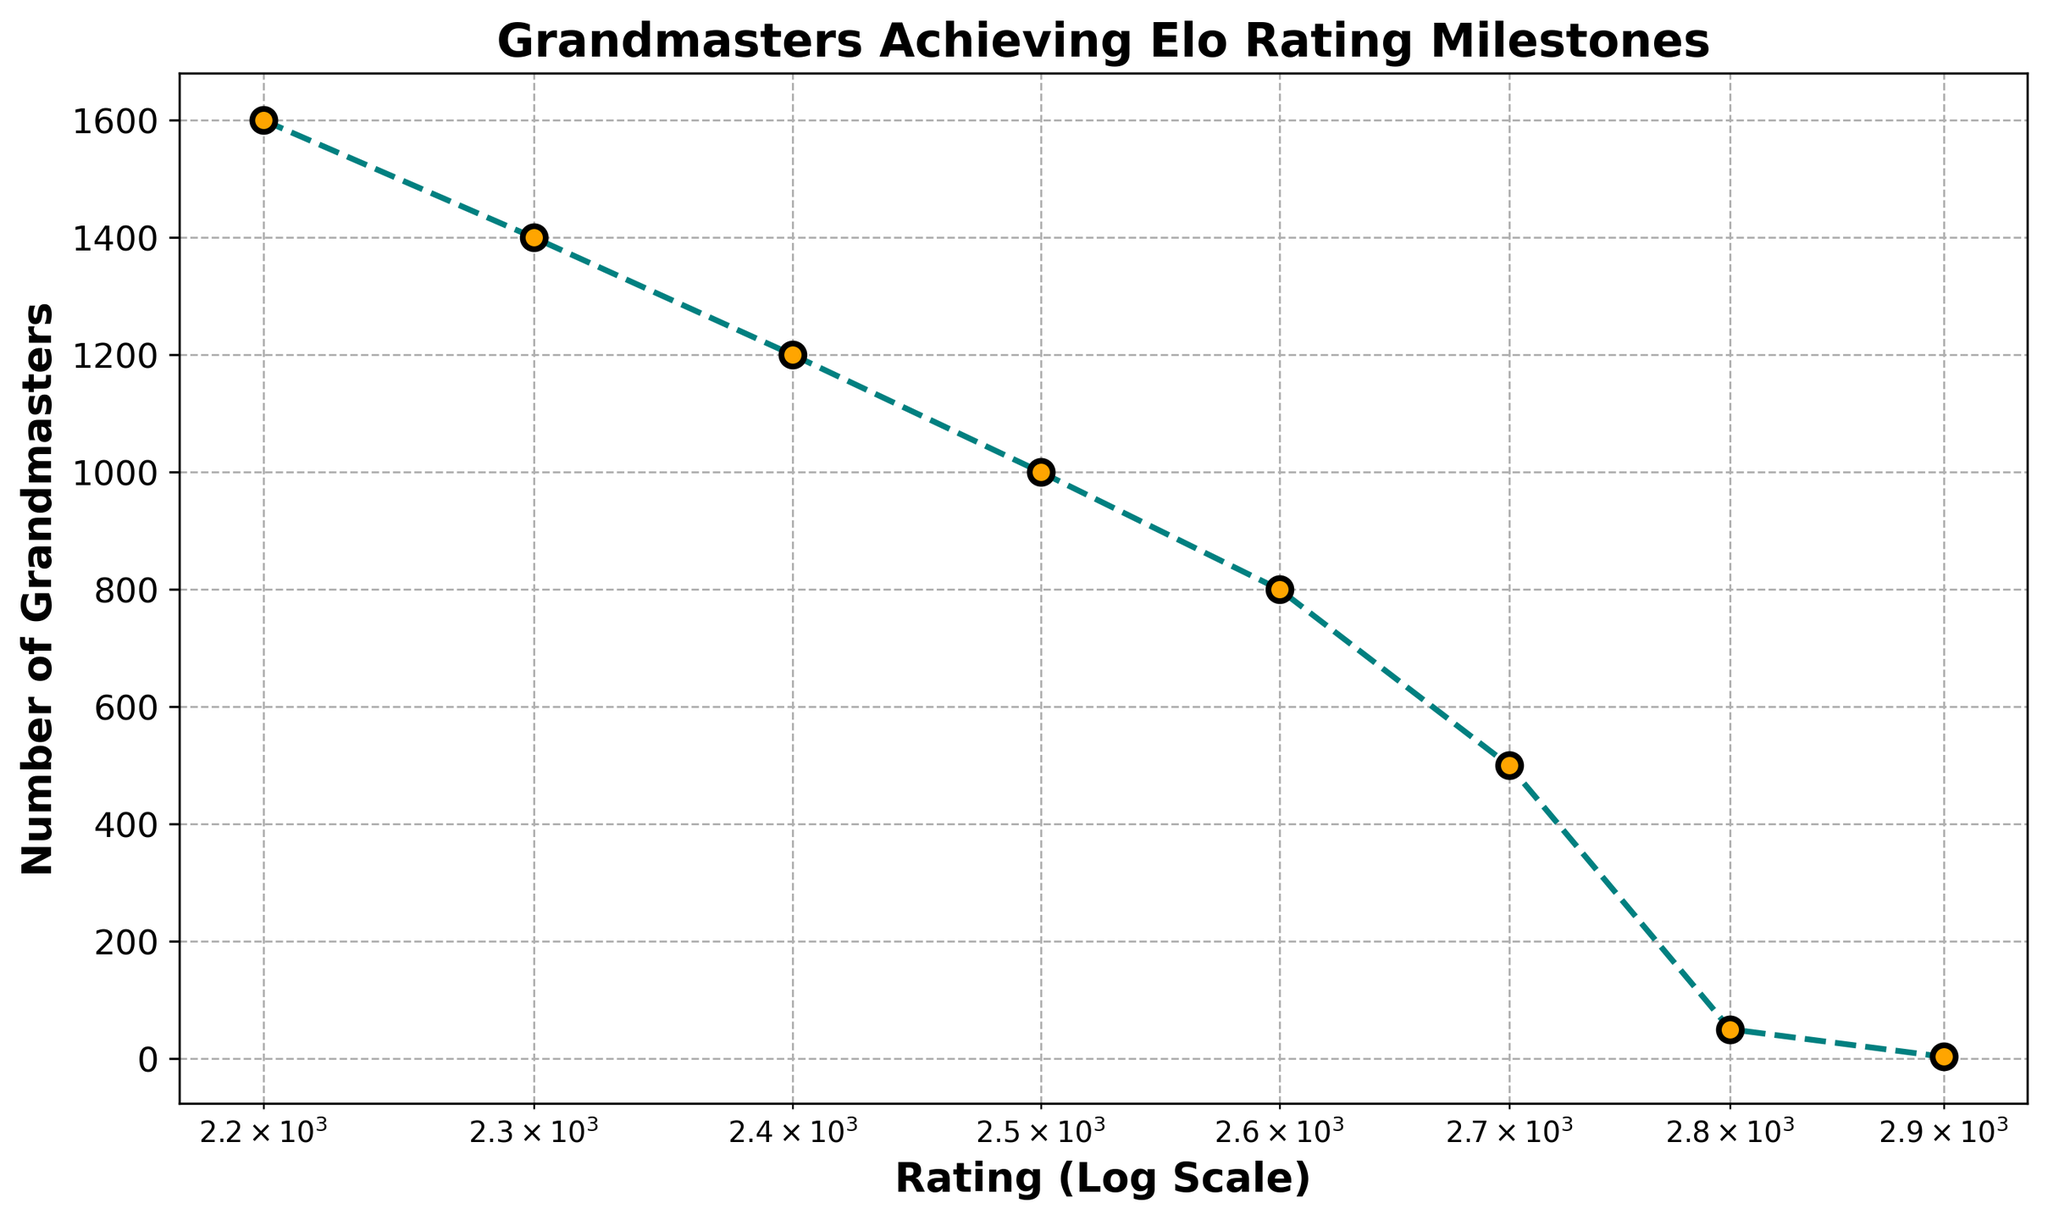Which Elo rating milestone has the largest number of grandmasters achieving it? By examining the plot, the data point with the highest vertical position represents the Elo rating with the most grandmasters. The 2200 rating has the largest number of grandmasters, with 1600 achieving it.
Answer: 2200 How many grandmasters have achieved a rating of 2800 or higher? Summing up the number of grandmasters at 2800 and 2900 ratings, we get 50 (2800) + 3 (2900) = 53 grandmasters.
Answer: 53 Between which two consecutive Elo ratings is there the largest drop in the number of grandmasters? By comparing the differences between the numbers of grandmasters at each successive rating, the largest drop is between 2700 (500) and 2800 (50), a difference of 450.
Answer: 2700 to 2800 What's the average number of grandmasters for ratings of 2600, 2700, and 2800? Add the numbers of grandmasters for these ratings (800 + 500 + 50) and divide by 3. The sum is 1350, so the average is 1350 / 3 = 450.
Answer: 450 Is the number of grandmasters achieving 2400 Elo rating more than double those achieving 2700? The number of grandmasters for 2400 is 1200, and for 2700 is 500. Doubling the number for 2700, we get 500 * 2 = 1000. Since 1200 > 1000, the number for 2400 is indeed more than double.
Answer: Yes Between which ratings do the grandmasters achieving them drop below 100? By comparing the counts, the transition happens between 2700 (500) and 2800 (50). At 2800, the number is below 100.
Answer: 2700 to 2800 How many grandmasters in total have achieved at least a 2600 rating? Sum the number of grandmasters from 2600 to 2900. This gives 800 (2600) + 500 (2700) + 50 (2800) + 3 (2900) = 1353.
Answer: 1353 What is the ratio of grandmasters achieving a 2500 rating to those achieving a 2900 rating? Divide the number of grandmasters at 2500 (1000) by those at 2900 (3). 1000 / 3 ≈ 333.33.
Answer: 333.33 